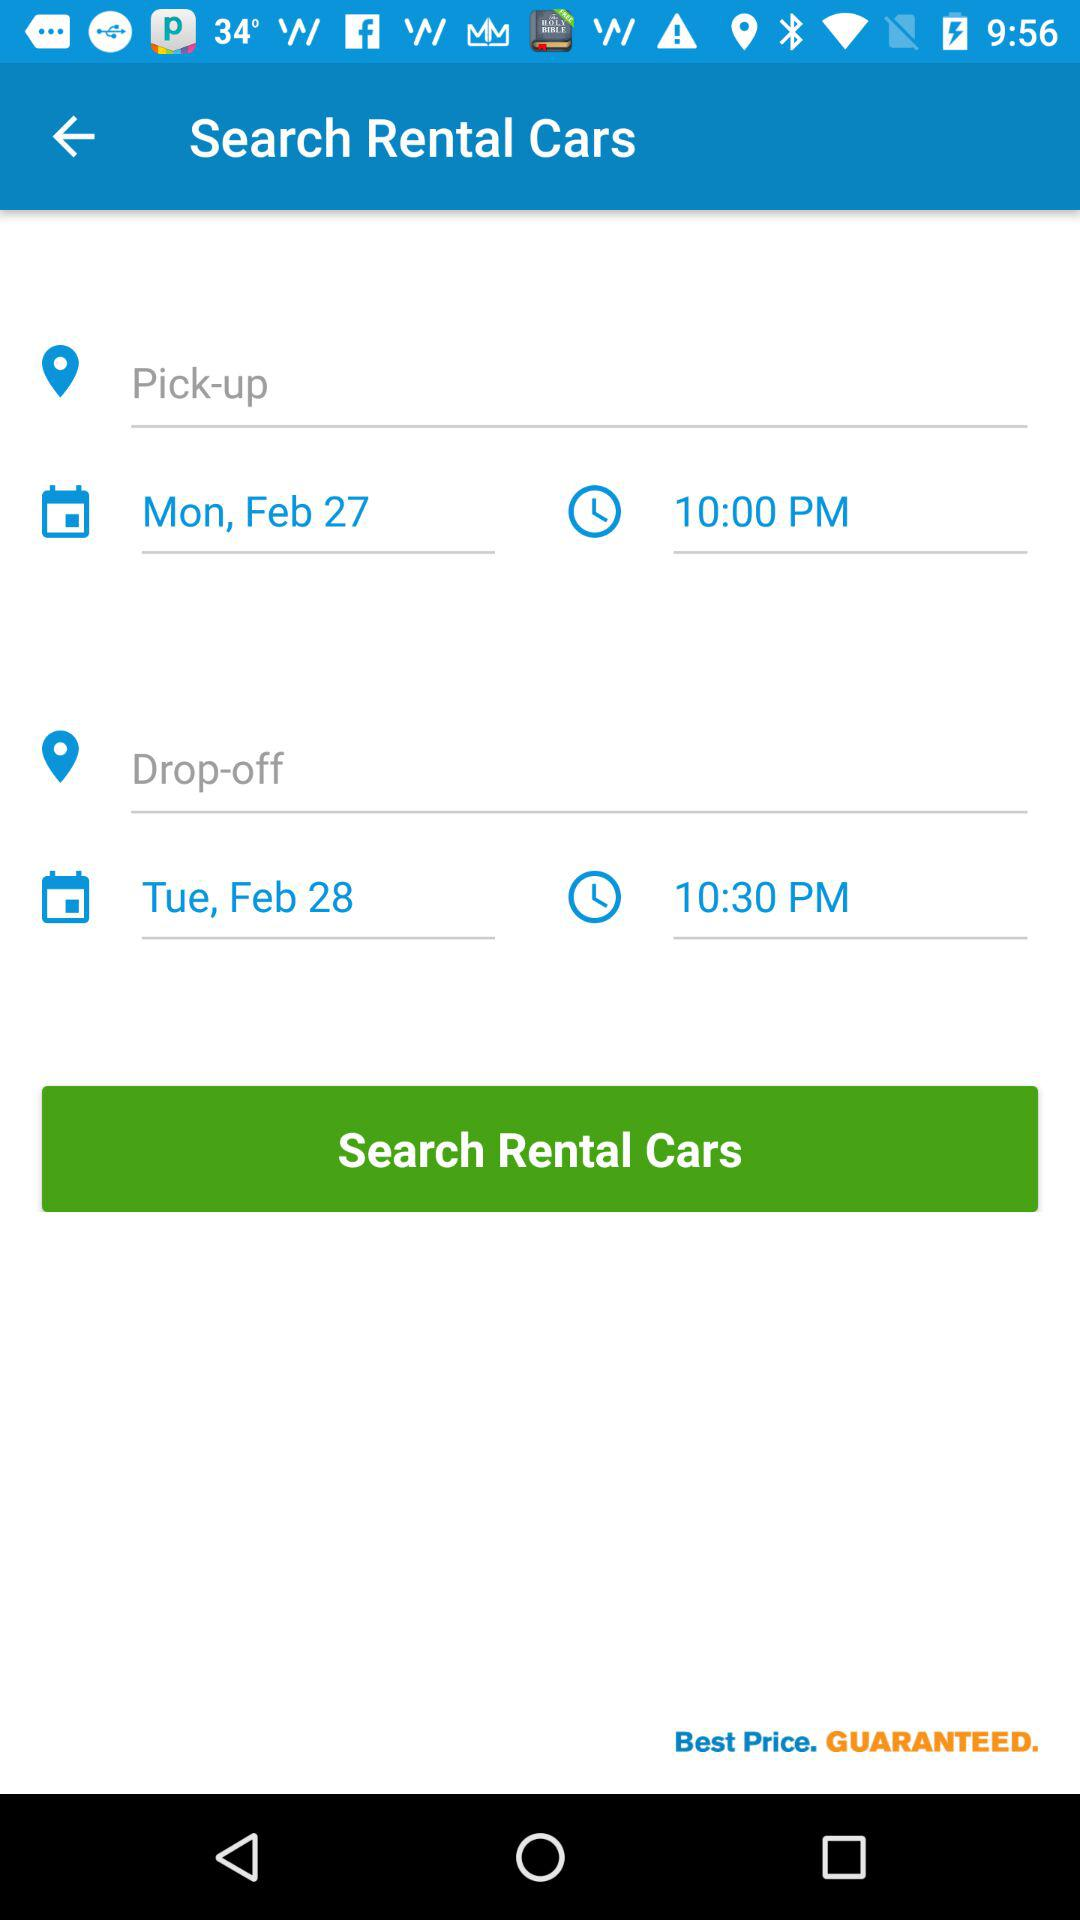How much later is the drop-off time than the pick-up time?
Answer the question using a single word or phrase. 30 minutes 